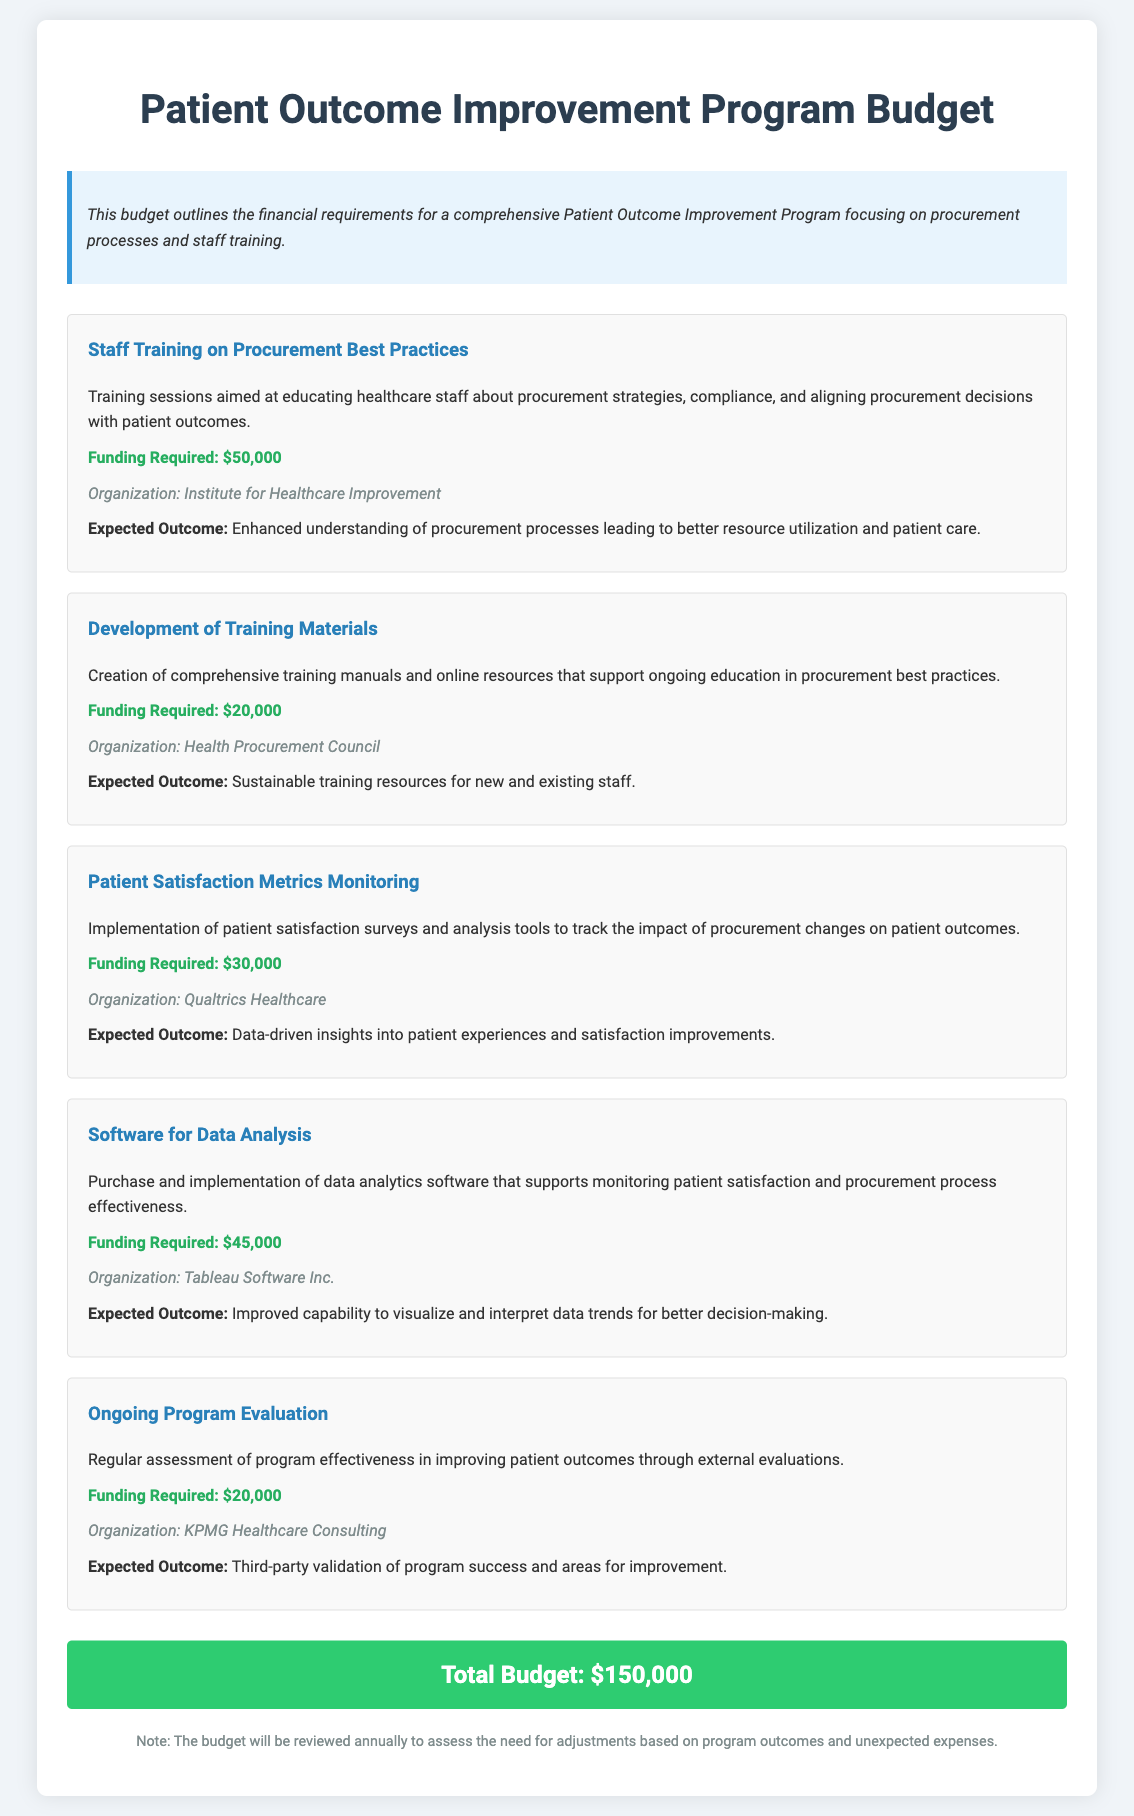What is the total budget for the program? The total budget is mentioned at the end of the document and is the cumulative sum of all budget items listed.
Answer: $150,000 Who is responsible for developing training materials? The organization listed for the development of training materials is found in the section detailing that item.
Answer: Health Procurement Council What is the funding required for Patient Satisfaction Metrics Monitoring? This is a specific value stated alongside the description of that budget item in the document.
Answer: $30,000 What is the expected outcome for Staff Training on Procurement Best Practices? The anticipated result is explicitly stated within the relevant section of the budget item.
Answer: Enhanced understanding of procurement processes leading to better resource utilization and patient care How much funding is allocated for Software for Data Analysis? The amount is given in the budget item focused on data analytics software.
Answer: $45,000 What organization is involved in ongoing program evaluation? The organization conducting the ongoing evaluation is specified in the appropriate budget item section.
Answer: KPMG Healthcare Consulting What is the purpose of the development of training materials? The function of creating training materials can be found in the description of that budget item.
Answer: Sustainable training resources for new and existing staff Which software organization is mentioned for procurement analysis? The organization providing the software is outlined in the respective budget item description.
Answer: Tableau Software Inc What is the expected outcome from monitoring patient satisfaction metrics? This outcome is detailed in the specific section regarding patient satisfaction and its monitoring.
Answer: Data-driven insights into patient experiences and satisfaction improvements 